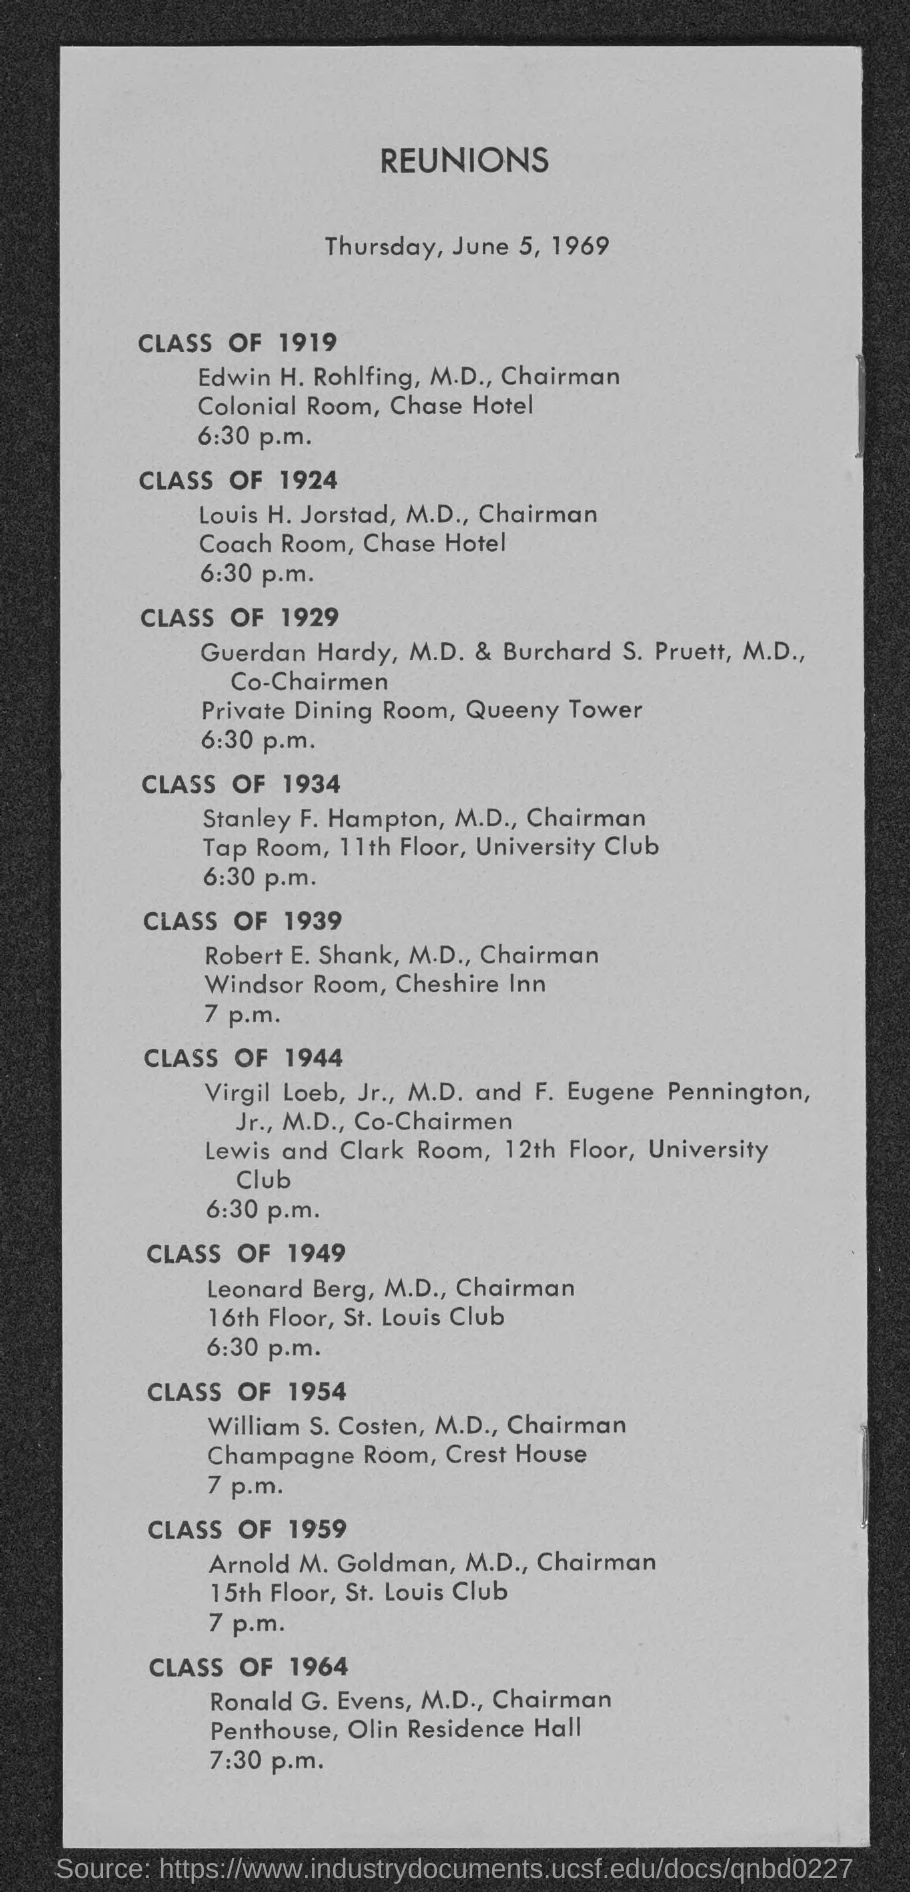Draw attention to some important aspects in this diagram. The venue for the class of 1954 is the Champagne room at Crest House. The venue for the class of 1919 is the Colonial room. The venue for the Class of 1939 is the Windsor Room. The venue for Class 1924 is the coach room. The venue for Class of 1929 is a private dining room. 